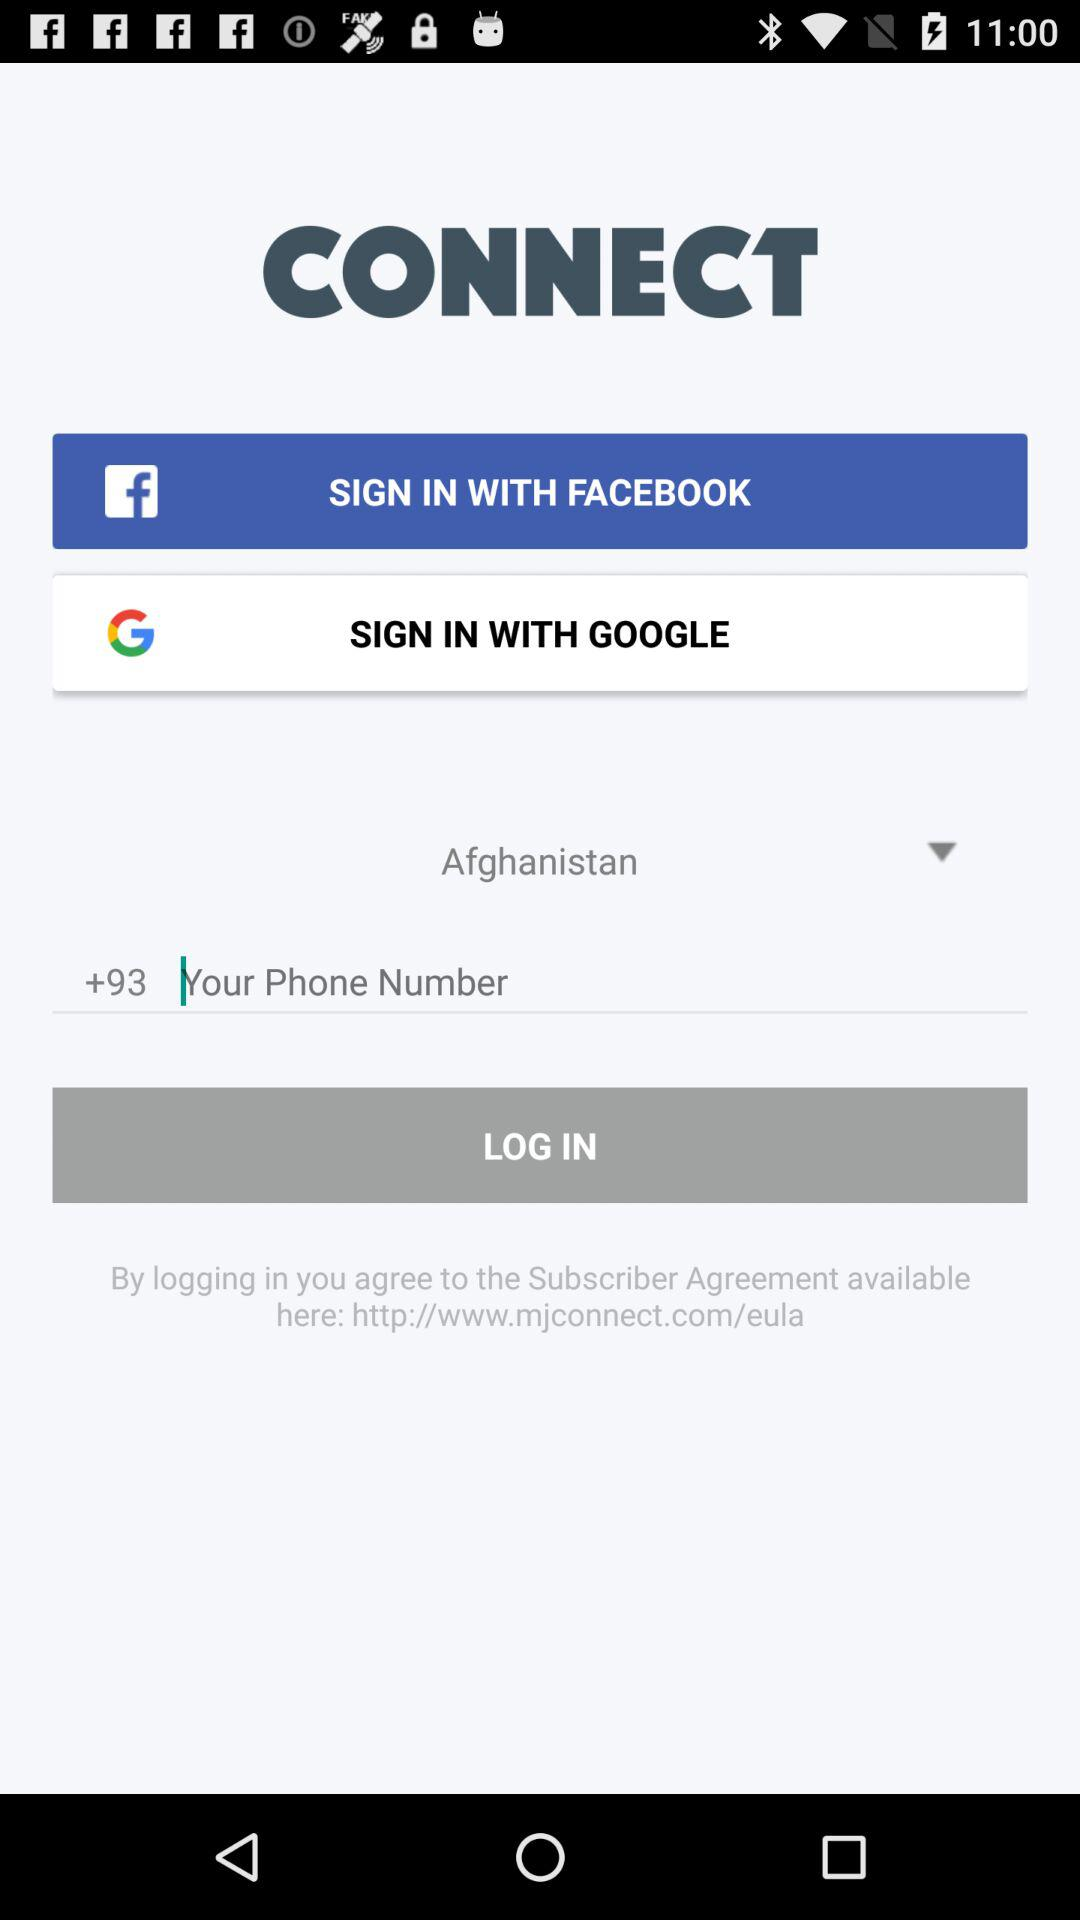What is the application name? The application name is "CONNECT". 